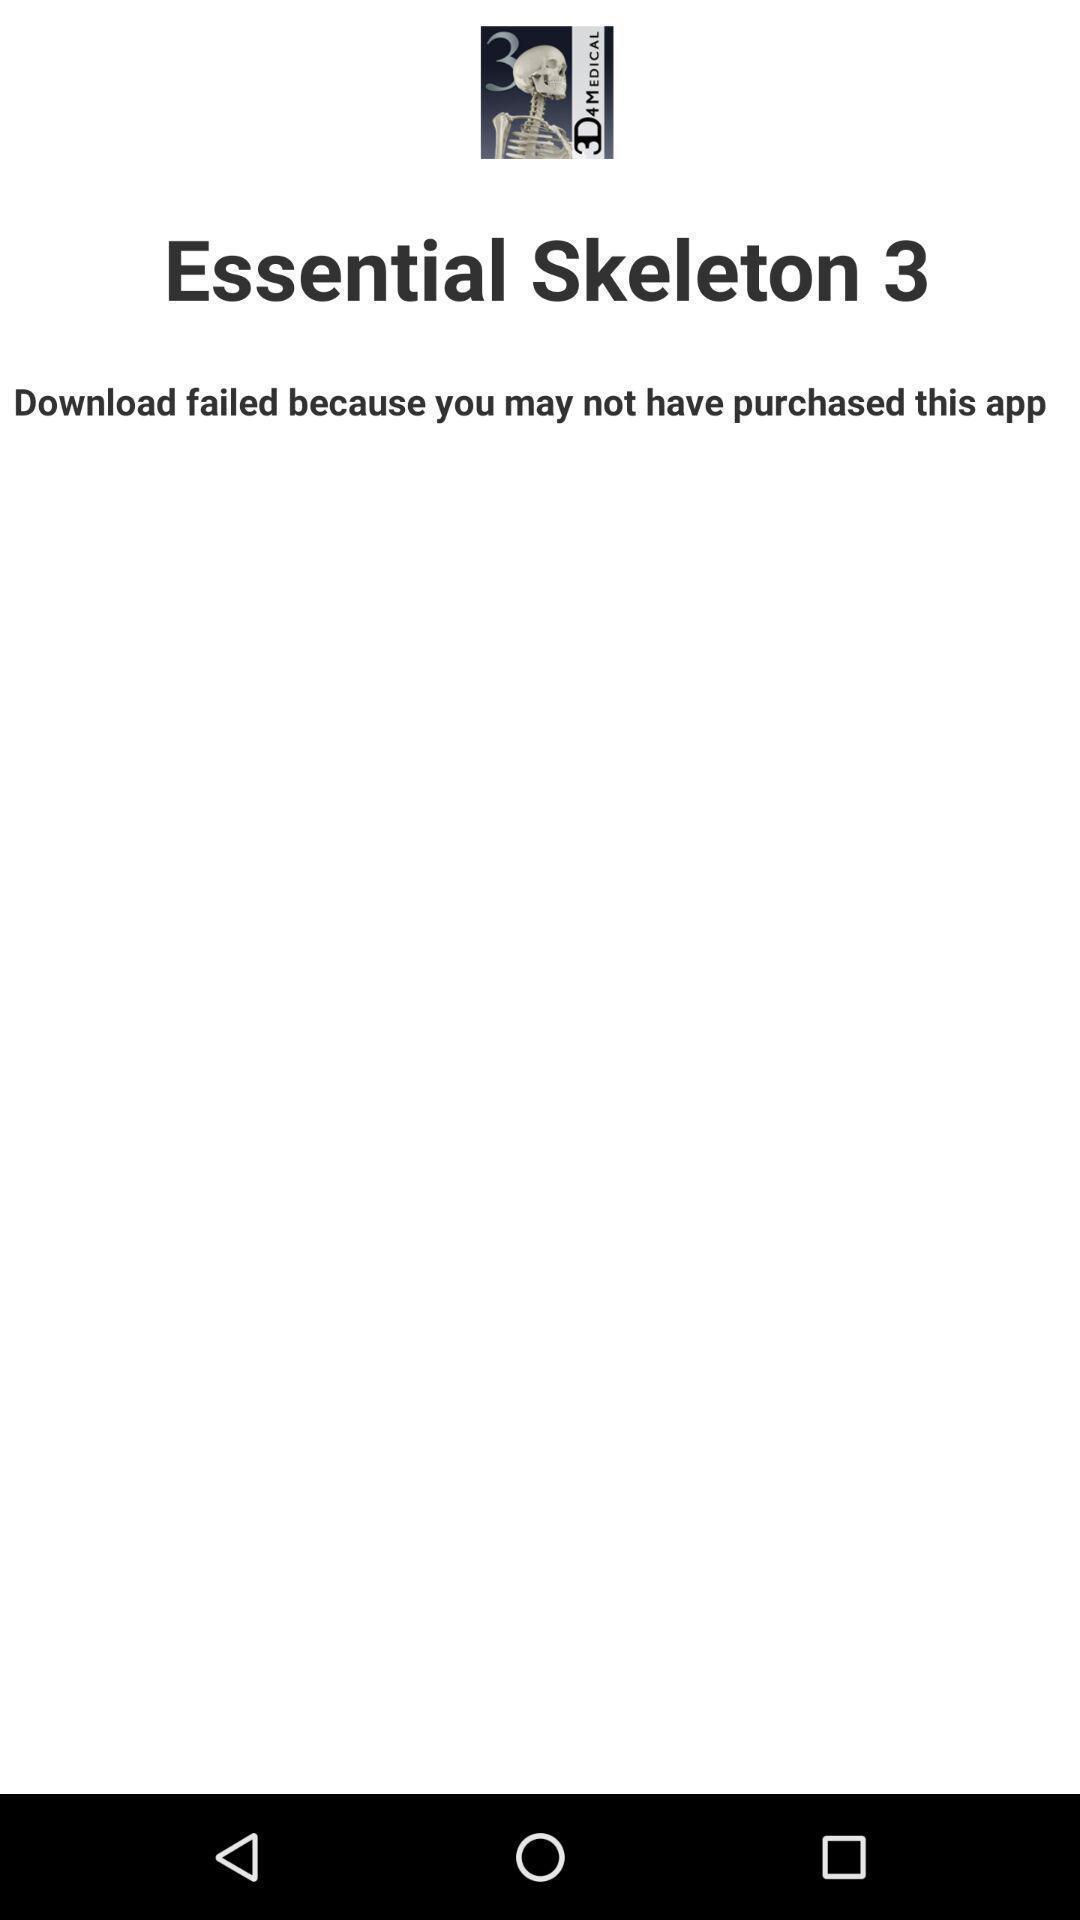Tell me what you see in this picture. Screen shows the details of a purchase. 